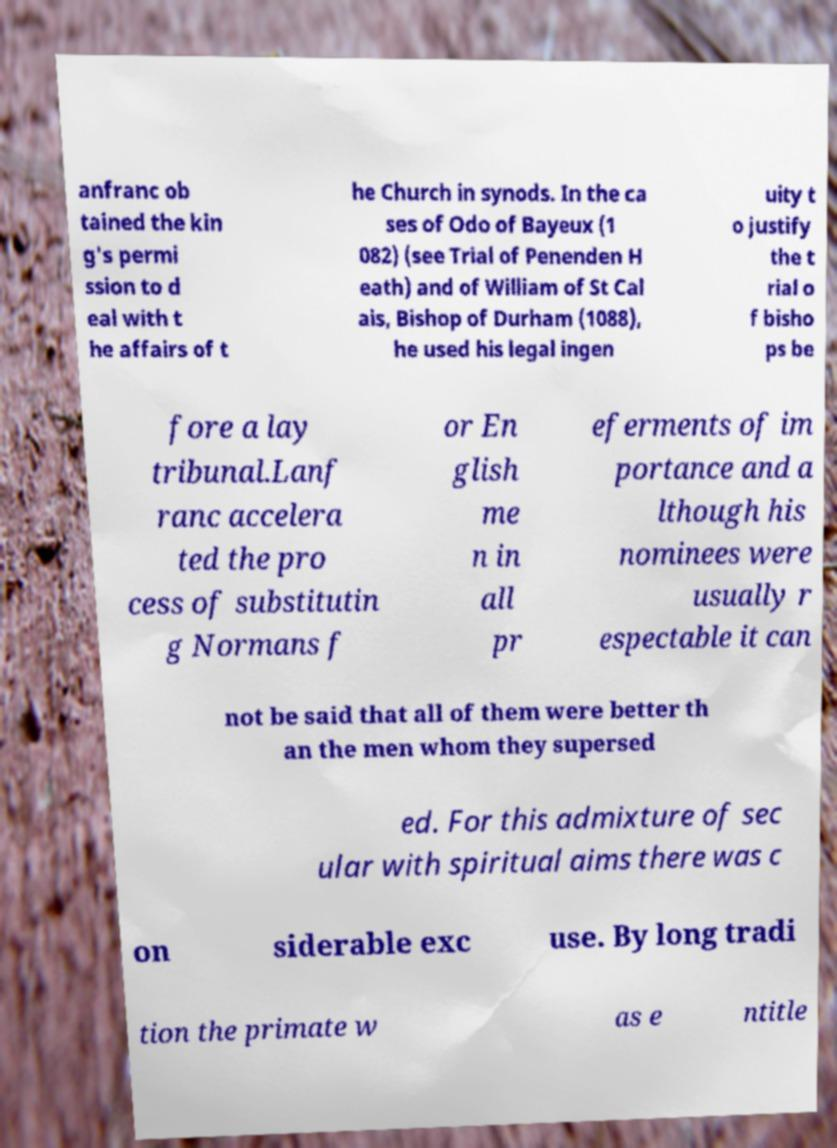There's text embedded in this image that I need extracted. Can you transcribe it verbatim? anfranc ob tained the kin g's permi ssion to d eal with t he affairs of t he Church in synods. In the ca ses of Odo of Bayeux (1 082) (see Trial of Penenden H eath) and of William of St Cal ais, Bishop of Durham (1088), he used his legal ingen uity t o justify the t rial o f bisho ps be fore a lay tribunal.Lanf ranc accelera ted the pro cess of substitutin g Normans f or En glish me n in all pr eferments of im portance and a lthough his nominees were usually r espectable it can not be said that all of them were better th an the men whom they supersed ed. For this admixture of sec ular with spiritual aims there was c on siderable exc use. By long tradi tion the primate w as e ntitle 